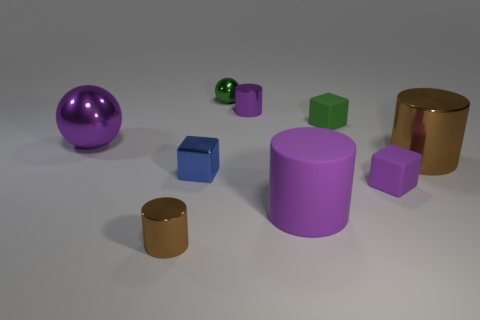There is a rubber cube that is the same color as the tiny metal sphere; what size is it?
Ensure brevity in your answer.  Small. Are there any small brown objects on the left side of the purple metal thing on the left side of the tiny metal sphere?
Provide a short and direct response. No. What number of things are purple things on the right side of the small blue shiny object or small metal things that are in front of the big brown thing?
Ensure brevity in your answer.  5. Is there anything else that is the same color as the small metallic sphere?
Provide a succinct answer. Yes. What is the color of the small cylinder that is in front of the big thing that is on the left side of the tiny thing that is to the left of the tiny blue metal block?
Offer a terse response. Brown. What is the size of the block behind the large brown thing to the right of the small green rubber thing?
Keep it short and to the point. Small. The tiny thing that is in front of the tiny blue shiny block and on the left side of the tiny shiny sphere is made of what material?
Ensure brevity in your answer.  Metal. There is a green matte object; is its size the same as the purple matte thing that is to the left of the small purple rubber thing?
Offer a terse response. No. Are any green shiny things visible?
Offer a very short reply. Yes. There is another purple thing that is the same shape as the tiny purple metallic object; what is its material?
Keep it short and to the point. Rubber. 